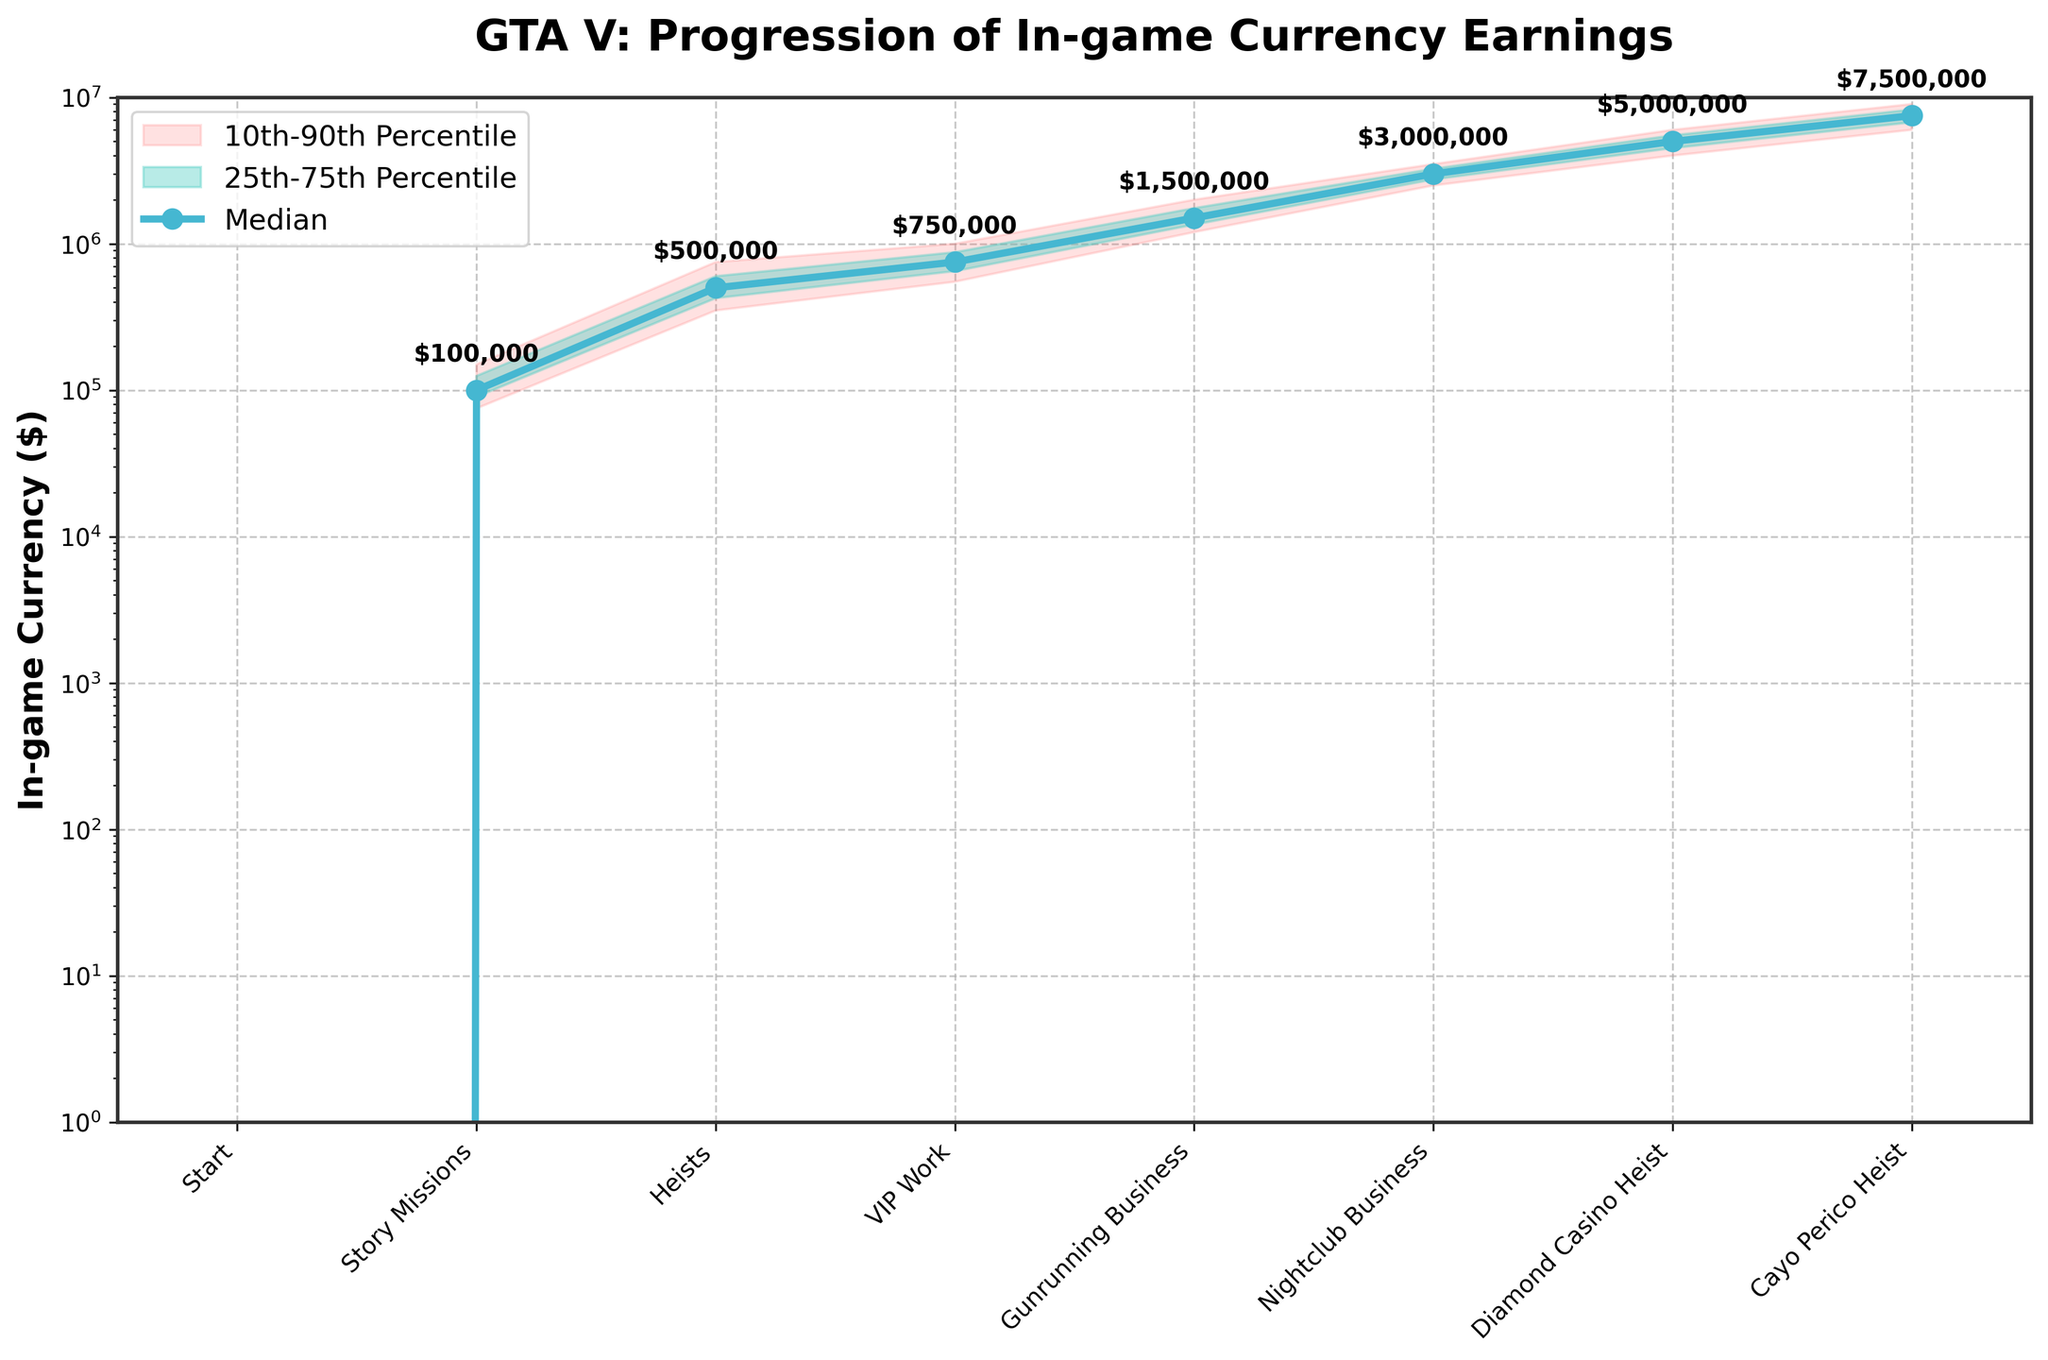What is the title of the chart? The title of the chart is displayed at the top of the figure.
Answer: GTA V: Progression of In-game Currency Earnings How many different activities are shown in the chart? The x-axis labels indicate the different activities presented in the chart.
Answer: Seven What is the range of the 10th-90th percentile earnings for Heists? The shaded area indicating the range for Heists spans from the 10th percentile to the 90th percentile.
Answer: 350,000 to 750,000 What's the median in-game currency earnings for the Diamond Casino Heist? The median is marked by a line with markers, and the values are annotated on this line. Check the point corresponding to the Diamond Casino Heist.
Answer: 5,000,000 Which activity has the highest median earnings? Among all the activities, find the one with the highest value on the median line and annotations.
Answer: Cayo Perico Heist By how much do the median earnings of Gunrunning Business surpass VIP Work? Subtract the median earnings of VIP Work from the median earnings of Gunrunning Business. The annotated values help in this comparison.
Answer: 1500000 - 750000 = 750000 Which two activities have a wider spread of earnings between the 10th and 90th percentiles? Compare the vertical spans of the shaded areas for each activity, checking for the widest ranges.
Answer: Cayo Perico Heist and Diamond Casino Heist What is the lowest 10th percentile value shown in the chart, and for which activity? Look at the shaded area indicating the 10th percentile value for each activity.
Answer: 0 for Start On which basis can an activity's earning distribution be considered most narrow? Compare the width of the shaded areas horizontally for different activities; the narrower the area, the less spread in earnings.
Answer: Story Missions 